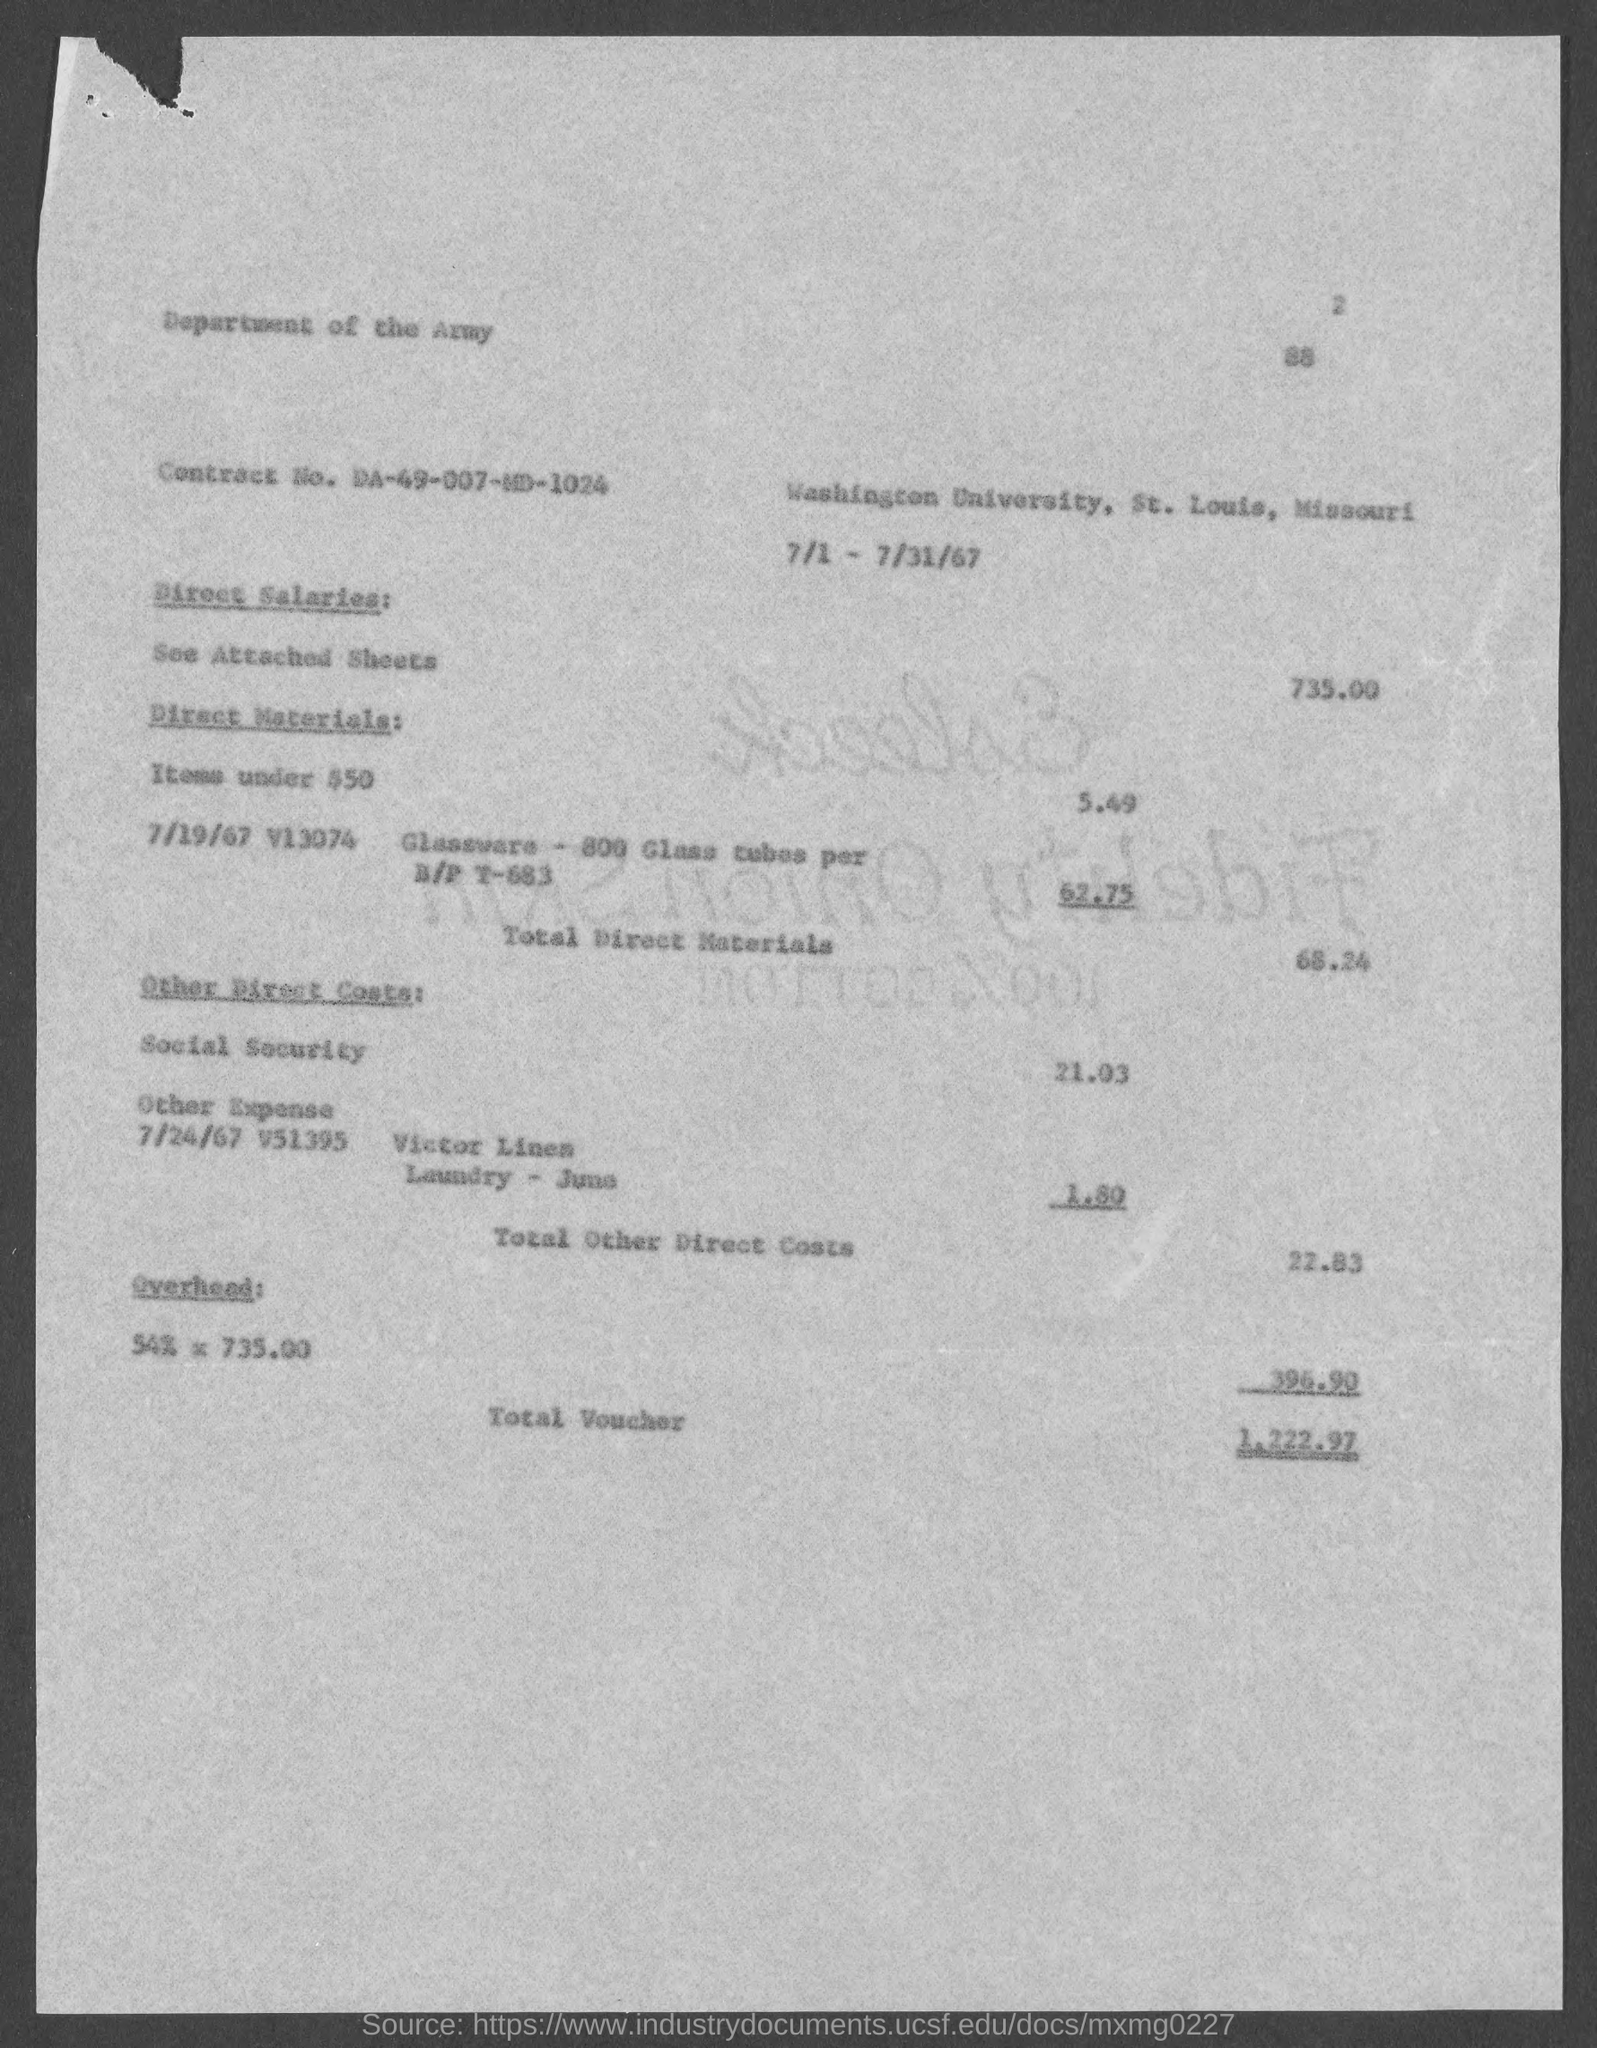Could you explain what might be included in the 'Other Direct Costs' on this voucher? The 'Other Direct Costs' category likely includes miscellaneous expenses directly related to the project or service being billed for. In this case, it includes costs for Social Security contributions and a specific laundry service provided by 'Victor Linen', which could be related to the laundering of work uniforms or materials used in the project. 